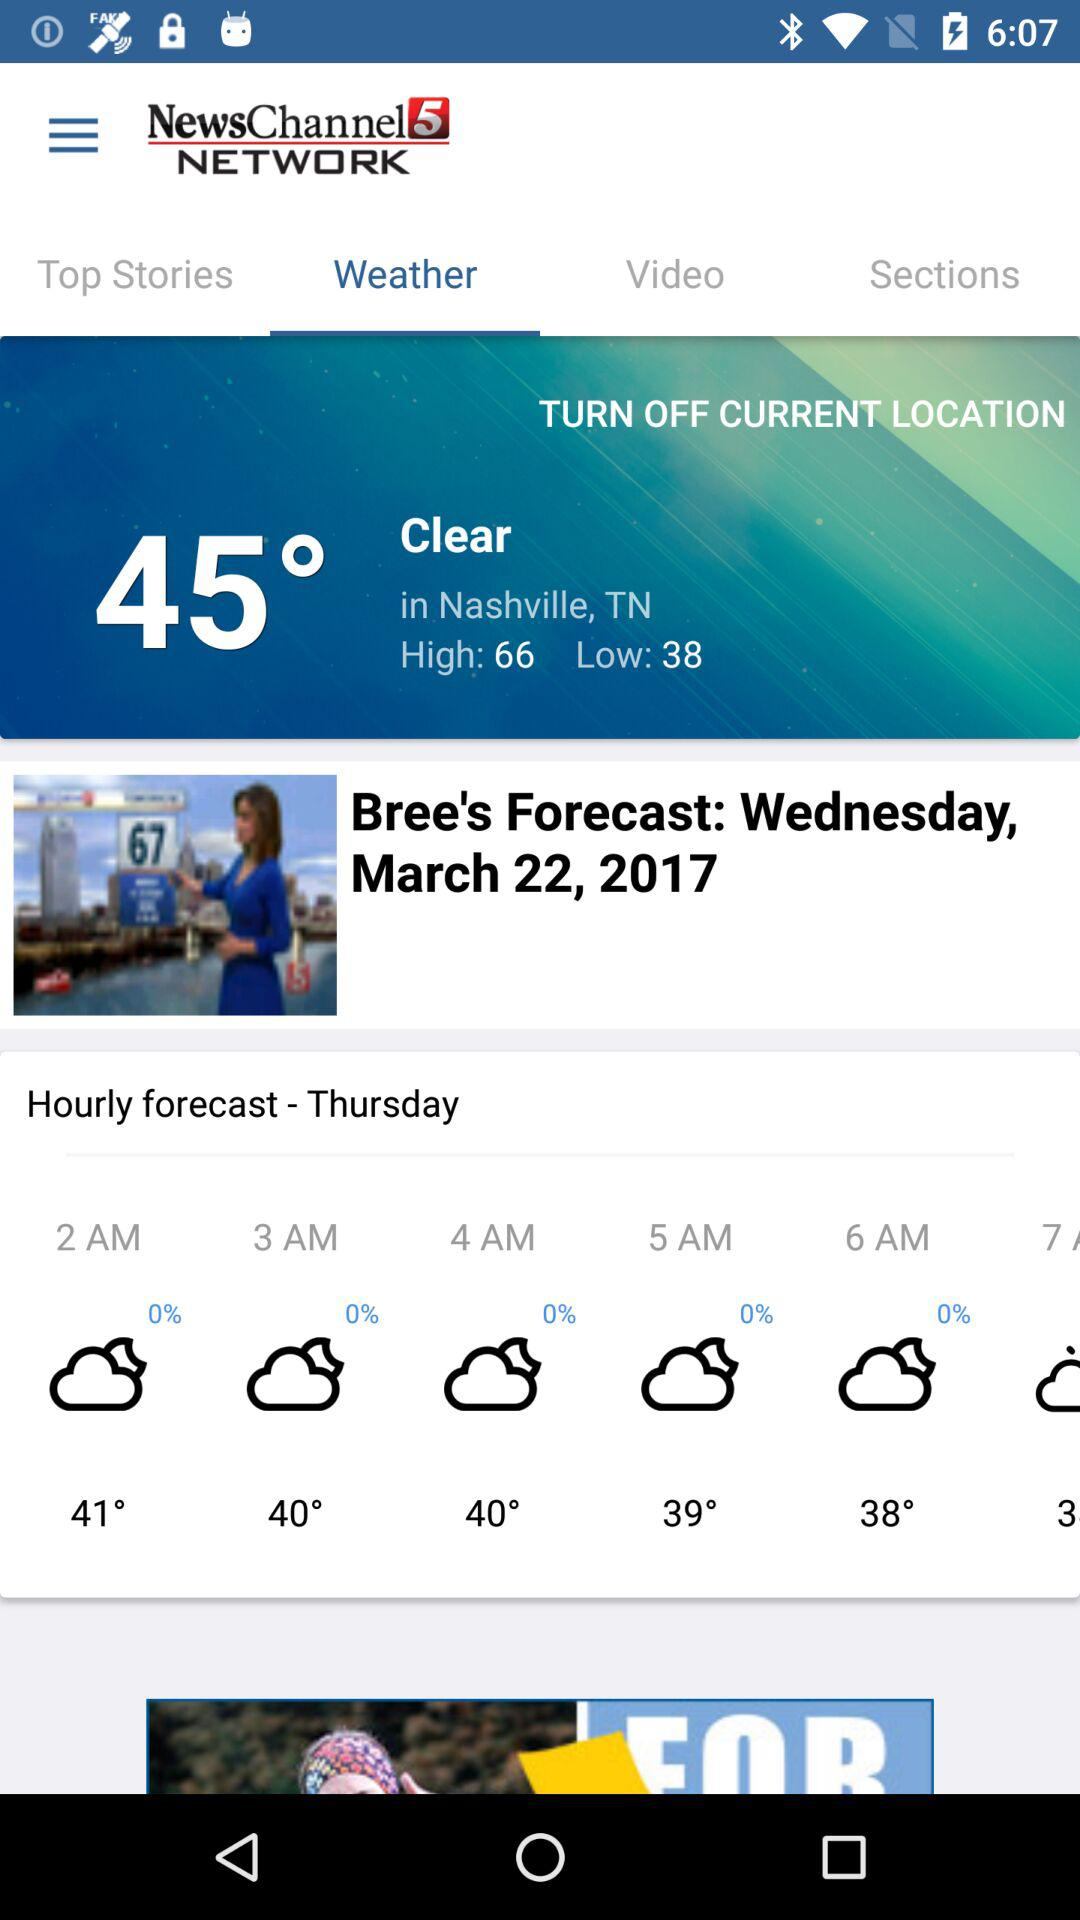How many degrees Fahrenheit warmer is the high temperature than the low temperature?
Answer the question using a single word or phrase. 28 